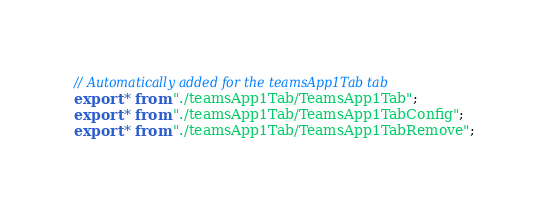<code> <loc_0><loc_0><loc_500><loc_500><_TypeScript_>// Automatically added for the teamsApp1Tab tab
export * from "./teamsApp1Tab/TeamsApp1Tab";
export * from "./teamsApp1Tab/TeamsApp1TabConfig";
export * from "./teamsApp1Tab/TeamsApp1TabRemove";
</code> 